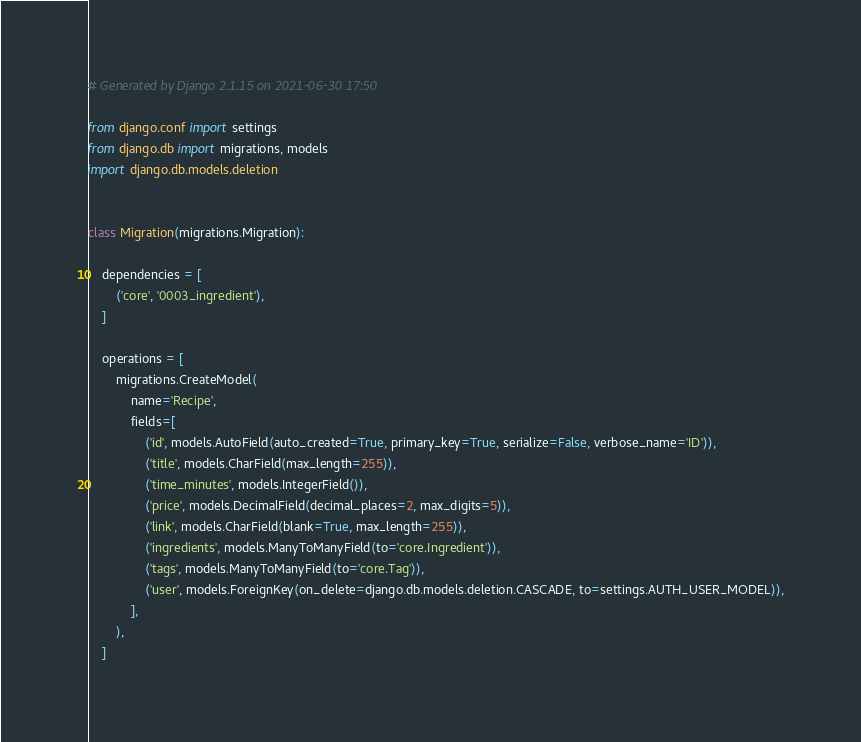<code> <loc_0><loc_0><loc_500><loc_500><_Python_># Generated by Django 2.1.15 on 2021-06-30 17:50

from django.conf import settings
from django.db import migrations, models
import django.db.models.deletion


class Migration(migrations.Migration):

    dependencies = [
        ('core', '0003_ingredient'),
    ]

    operations = [
        migrations.CreateModel(
            name='Recipe',
            fields=[
                ('id', models.AutoField(auto_created=True, primary_key=True, serialize=False, verbose_name='ID')),
                ('title', models.CharField(max_length=255)),
                ('time_minutes', models.IntegerField()),
                ('price', models.DecimalField(decimal_places=2, max_digits=5)),
                ('link', models.CharField(blank=True, max_length=255)),
                ('ingredients', models.ManyToManyField(to='core.Ingredient')),
                ('tags', models.ManyToManyField(to='core.Tag')),
                ('user', models.ForeignKey(on_delete=django.db.models.deletion.CASCADE, to=settings.AUTH_USER_MODEL)),
            ],
        ),
    ]
</code> 